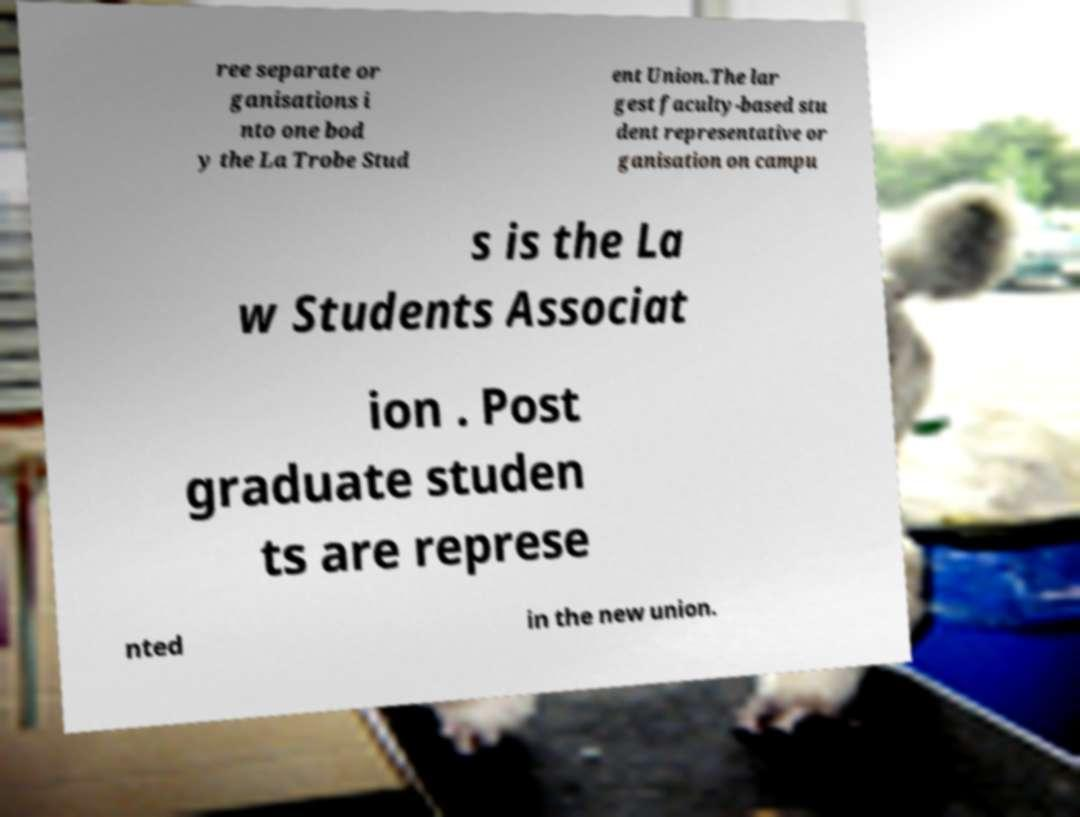Could you extract and type out the text from this image? ree separate or ganisations i nto one bod y the La Trobe Stud ent Union.The lar gest faculty-based stu dent representative or ganisation on campu s is the La w Students Associat ion . Post graduate studen ts are represe nted in the new union. 